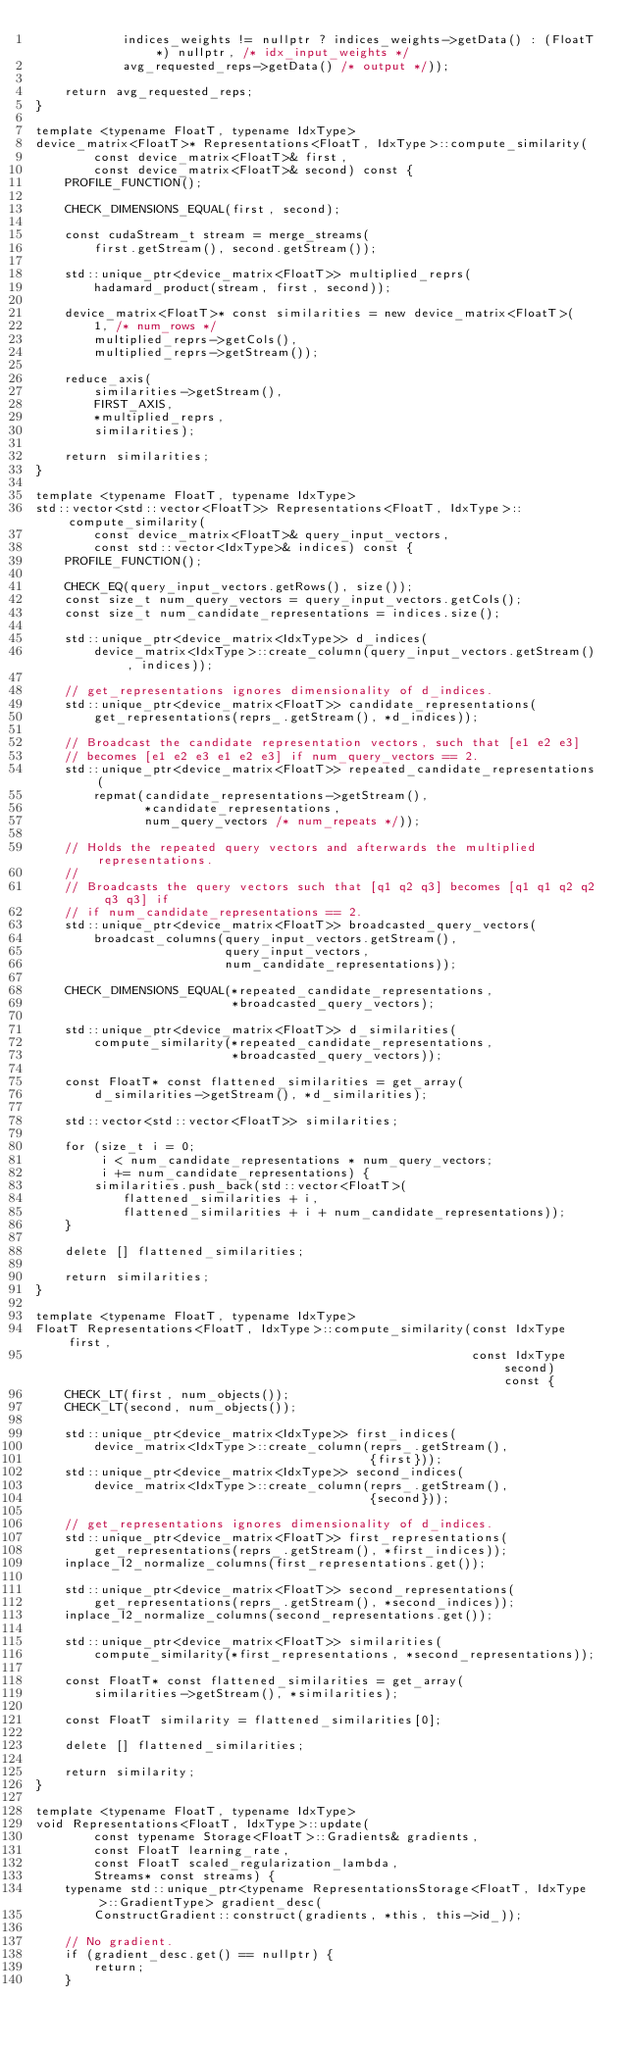Convert code to text. <code><loc_0><loc_0><loc_500><loc_500><_Cuda_>            indices_weights != nullptr ? indices_weights->getData() : (FloatT*) nullptr, /* idx_input_weights */
            avg_requested_reps->getData() /* output */));

    return avg_requested_reps;
}

template <typename FloatT, typename IdxType>
device_matrix<FloatT>* Representations<FloatT, IdxType>::compute_similarity(
        const device_matrix<FloatT>& first,
        const device_matrix<FloatT>& second) const {
    PROFILE_FUNCTION();

    CHECK_DIMENSIONS_EQUAL(first, second);

    const cudaStream_t stream = merge_streams(
        first.getStream(), second.getStream());

    std::unique_ptr<device_matrix<FloatT>> multiplied_reprs(
        hadamard_product(stream, first, second));

    device_matrix<FloatT>* const similarities = new device_matrix<FloatT>(
        1, /* num_rows */
        multiplied_reprs->getCols(),
        multiplied_reprs->getStream());

    reduce_axis(
        similarities->getStream(),
        FIRST_AXIS,
        *multiplied_reprs,
        similarities);

    return similarities;
}

template <typename FloatT, typename IdxType>
std::vector<std::vector<FloatT>> Representations<FloatT, IdxType>::compute_similarity(
        const device_matrix<FloatT>& query_input_vectors,
        const std::vector<IdxType>& indices) const {
    PROFILE_FUNCTION();

    CHECK_EQ(query_input_vectors.getRows(), size());
    const size_t num_query_vectors = query_input_vectors.getCols();
    const size_t num_candidate_representations = indices.size();

    std::unique_ptr<device_matrix<IdxType>> d_indices(
        device_matrix<IdxType>::create_column(query_input_vectors.getStream(), indices));

    // get_representations ignores dimensionality of d_indices.
    std::unique_ptr<device_matrix<FloatT>> candidate_representations(
        get_representations(reprs_.getStream(), *d_indices));

    // Broadcast the candidate representation vectors, such that [e1 e2 e3]
    // becomes [e1 e2 e3 e1 e2 e3] if num_query_vectors == 2.
    std::unique_ptr<device_matrix<FloatT>> repeated_candidate_representations(
        repmat(candidate_representations->getStream(),
               *candidate_representations,
               num_query_vectors /* num_repeats */));

    // Holds the repeated query vectors and afterwards the multiplied representations.
    //
    // Broadcasts the query vectors such that [q1 q2 q3] becomes [q1 q1 q2 q2 q3 q3] if
    // if num_candidate_representations == 2.
    std::unique_ptr<device_matrix<FloatT>> broadcasted_query_vectors(
        broadcast_columns(query_input_vectors.getStream(),
                          query_input_vectors,
                          num_candidate_representations));

    CHECK_DIMENSIONS_EQUAL(*repeated_candidate_representations,
                           *broadcasted_query_vectors);

    std::unique_ptr<device_matrix<FloatT>> d_similarities(
        compute_similarity(*repeated_candidate_representations,
                           *broadcasted_query_vectors));

    const FloatT* const flattened_similarities = get_array(
        d_similarities->getStream(), *d_similarities);

    std::vector<std::vector<FloatT>> similarities;

    for (size_t i = 0;
         i < num_candidate_representations * num_query_vectors;
         i += num_candidate_representations) {
        similarities.push_back(std::vector<FloatT>(
            flattened_similarities + i,
            flattened_similarities + i + num_candidate_representations));
    }

    delete [] flattened_similarities;

    return similarities;
}

template <typename FloatT, typename IdxType>
FloatT Representations<FloatT, IdxType>::compute_similarity(const IdxType first,
                                                            const IdxType second) const {
    CHECK_LT(first, num_objects());
    CHECK_LT(second, num_objects());

    std::unique_ptr<device_matrix<IdxType>> first_indices(
        device_matrix<IdxType>::create_column(reprs_.getStream(),
                                              {first}));
    std::unique_ptr<device_matrix<IdxType>> second_indices(
        device_matrix<IdxType>::create_column(reprs_.getStream(),
                                              {second}));

    // get_representations ignores dimensionality of d_indices.
    std::unique_ptr<device_matrix<FloatT>> first_representations(
        get_representations(reprs_.getStream(), *first_indices));
    inplace_l2_normalize_columns(first_representations.get());

    std::unique_ptr<device_matrix<FloatT>> second_representations(
        get_representations(reprs_.getStream(), *second_indices));
    inplace_l2_normalize_columns(second_representations.get());

    std::unique_ptr<device_matrix<FloatT>> similarities(
        compute_similarity(*first_representations, *second_representations));

    const FloatT* const flattened_similarities = get_array(
        similarities->getStream(), *similarities);

    const FloatT similarity = flattened_similarities[0];

    delete [] flattened_similarities;

    return similarity;
}

template <typename FloatT, typename IdxType>
void Representations<FloatT, IdxType>::update(
        const typename Storage<FloatT>::Gradients& gradients,
        const FloatT learning_rate,
        const FloatT scaled_regularization_lambda,
        Streams* const streams) {
    typename std::unique_ptr<typename RepresentationsStorage<FloatT, IdxType>::GradientType> gradient_desc(
        ConstructGradient::construct(gradients, *this, this->id_));

    // No gradient.
    if (gradient_desc.get() == nullptr) {
        return;
    }
</code> 